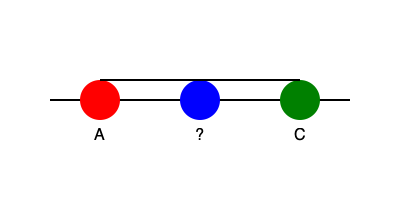In the DNA base pairing schematic above, which nucleotide should replace the question mark to form a complementary base pair with Cytosine (C)? To answer this question, let's follow these steps:

1. Recall the basic rules of DNA base pairing:
   - Adenine (A) pairs with Thymine (T)
   - Cytosine (C) pairs with Guanine (G)

2. Identify the given information:
   - The green circle on the right is labeled "C", representing Cytosine

3. Apply the base pairing rule:
   - Since Cytosine (C) is present, its complementary base must be Guanine (G)

4. Conclude:
   - The nucleotide that should replace the question mark is Guanine (G)

This base pairing is crucial for the structural integrity of the DNA double helix and plays a vital role in processes such as DNA replication and transcription, which are fundamental to genetic information storage and expression.
Answer: Guanine (G) 